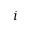<formula> <loc_0><loc_0><loc_500><loc_500>i</formula> 